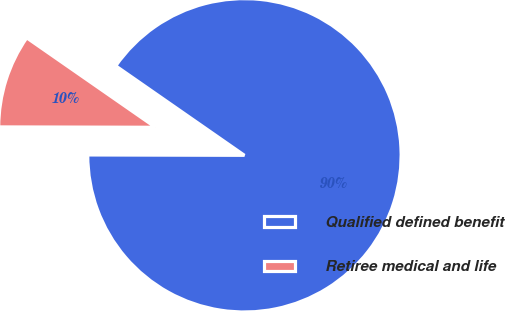Convert chart to OTSL. <chart><loc_0><loc_0><loc_500><loc_500><pie_chart><fcel>Qualified defined benefit<fcel>Retiree medical and life<nl><fcel>90.37%<fcel>9.63%<nl></chart> 